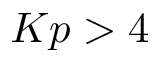Convert formula to latex. <formula><loc_0><loc_0><loc_500><loc_500>K p > 4</formula> 